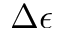<formula> <loc_0><loc_0><loc_500><loc_500>\Delta \epsilon</formula> 